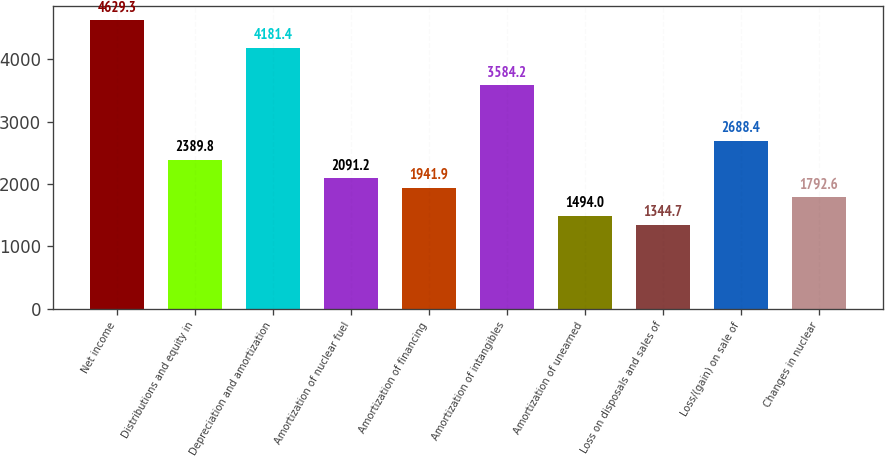Convert chart to OTSL. <chart><loc_0><loc_0><loc_500><loc_500><bar_chart><fcel>Net income<fcel>Distributions and equity in<fcel>Depreciation and amortization<fcel>Amortization of nuclear fuel<fcel>Amortization of financing<fcel>Amortization of intangibles<fcel>Amortization of unearned<fcel>Loss on disposals and sales of<fcel>Loss/(gain) on sale of<fcel>Changes in nuclear<nl><fcel>4629.3<fcel>2389.8<fcel>4181.4<fcel>2091.2<fcel>1941.9<fcel>3584.2<fcel>1494<fcel>1344.7<fcel>2688.4<fcel>1792.6<nl></chart> 